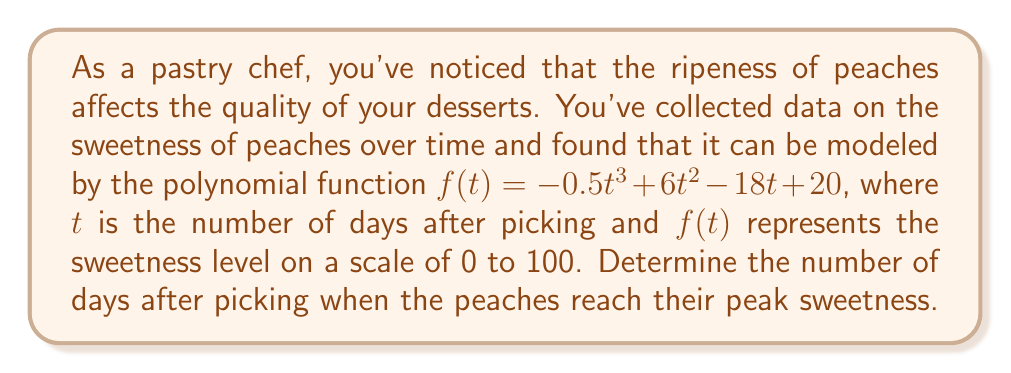Can you answer this question? To find the peak sweetness, we need to determine the maximum point of the given polynomial function. This can be done by following these steps:

1. Find the derivative of the function:
   $f'(t) = -1.5t^2 + 12t - 18$

2. Set the derivative equal to zero and solve for t:
   $-1.5t^2 + 12t - 18 = 0$

3. This is a quadratic equation. We can solve it using the quadratic formula:
   $t = \frac{-b \pm \sqrt{b^2 - 4ac}}{2a}$

   Where $a = -1.5$, $b = 12$, and $c = -18$

4. Substituting these values:
   $t = \frac{-12 \pm \sqrt{12^2 - 4(-1.5)(-18)}}{2(-1.5)}$
   $= \frac{-12 \pm \sqrt{144 - 108}}{-3}$
   $= \frac{-12 \pm \sqrt{36}}{-3}$
   $= \frac{-12 \pm 6}{-3}$

5. This gives us two solutions:
   $t_1 = \frac{-12 + 6}{-3} = 2$
   $t_2 = \frac{-12 - 6}{-3} = 6$

6. To determine which of these is the maximum (peak sweetness), we can check the second derivative:
   $f''(t) = -3t + 12$

7. Evaluating $f''(t)$ at $t = 2$ and $t = 6$:
   $f''(2) = -3(2) + 12 = 6$ (positive, indicating a minimum)
   $f''(6) = -3(6) + 12 = -6$ (negative, indicating a maximum)

Therefore, the peak sweetness occurs at $t = 6$ days after picking.
Answer: The peaches reach their peak sweetness 6 days after picking. 